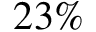Convert formula to latex. <formula><loc_0><loc_0><loc_500><loc_500>2 3 \%</formula> 